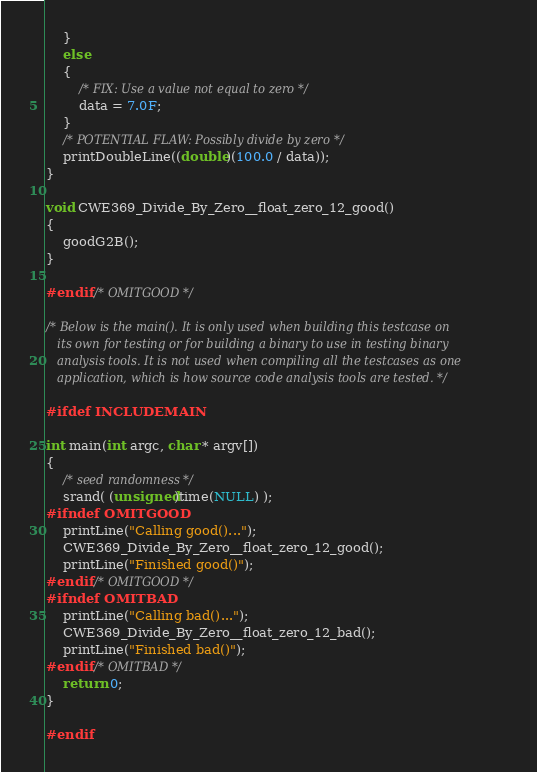Convert code to text. <code><loc_0><loc_0><loc_500><loc_500><_C_>    }
    else
    {
        /* FIX: Use a value not equal to zero */
        data = 7.0F;
    }
    /* POTENTIAL FLAW: Possibly divide by zero */
    printDoubleLine((double)(100.0 / data));
}

void CWE369_Divide_By_Zero__float_zero_12_good()
{
    goodG2B();
}

#endif /* OMITGOOD */

/* Below is the main(). It is only used when building this testcase on
   its own for testing or for building a binary to use in testing binary
   analysis tools. It is not used when compiling all the testcases as one
   application, which is how source code analysis tools are tested. */

#ifdef INCLUDEMAIN

int main(int argc, char * argv[])
{
    /* seed randomness */
    srand( (unsigned)time(NULL) );
#ifndef OMITGOOD
    printLine("Calling good()...");
    CWE369_Divide_By_Zero__float_zero_12_good();
    printLine("Finished good()");
#endif /* OMITGOOD */
#ifndef OMITBAD
    printLine("Calling bad()...");
    CWE369_Divide_By_Zero__float_zero_12_bad();
    printLine("Finished bad()");
#endif /* OMITBAD */
    return 0;
}

#endif
</code> 